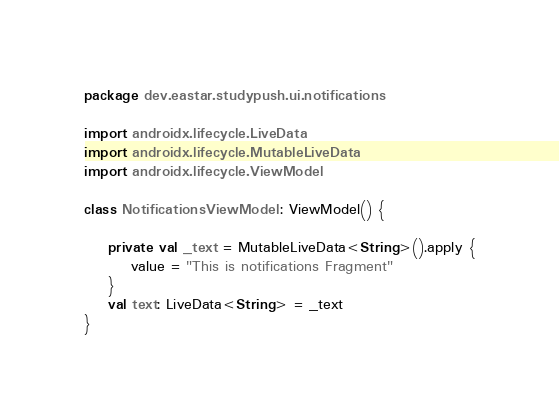Convert code to text. <code><loc_0><loc_0><loc_500><loc_500><_Kotlin_>package dev.eastar.studypush.ui.notifications

import androidx.lifecycle.LiveData
import androidx.lifecycle.MutableLiveData
import androidx.lifecycle.ViewModel

class NotificationsViewModel : ViewModel() {

    private val _text = MutableLiveData<String>().apply {
        value = "This is notifications Fragment"
    }
    val text: LiveData<String> = _text
}</code> 